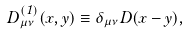Convert formula to latex. <formula><loc_0><loc_0><loc_500><loc_500>D ^ { ( 1 ) } _ { \mu \nu } ( x , y ) \equiv \delta _ { \mu \nu } D ( x - y ) ,</formula> 